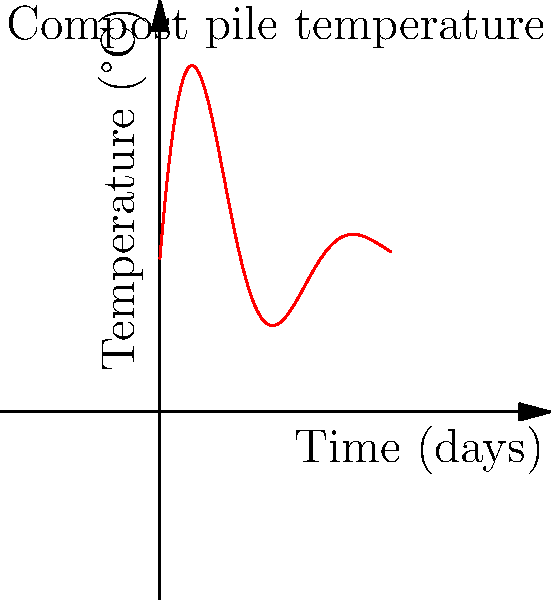At the Indian Land Fall Festival's sustainability booth, you're explaining the physics of composting. The graph shows the temperature variation in a compost pile over time. What physical process is primarily responsible for the initial temperature rise, and approximately how long does it take for the compost pile to reach its peak temperature? To answer this question, let's analyze the graph and the physics of composting:

1. Initial temperature rise:
   The graph shows a rapid increase in temperature at the beginning of the composting process. This is primarily due to the exothermic reactions of microorganisms breaking down organic matter.

2. Peak temperature:
   Looking at the graph, we can see that the temperature reaches its maximum at approximately 5 days.

3. Physical process explanation:
   a) As microorganisms decompose organic matter, they release heat as a byproduct of their metabolic activities.
   b) This process is exothermic, meaning it releases heat into the surrounding compost pile.
   c) The heat accumulates faster than it can dissipate, causing the temperature to rise.

4. Importance of temperature in composting:
   a) Higher temperatures (40-60°C) promote the growth of thermophilic bacteria, which are more efficient at breaking down organic matter.
   b) These temperatures also help kill pathogens and weed seeds in the compost.

5. Temperature decline:
   After the peak, the temperature gradually decreases as:
   a) The easily decomposable materials are consumed.
   b) The microbial activity slows down.
   c) Heat loss to the environment becomes more significant than heat generation.

The graph illustrates this entire process, showing the rapid initial rise, peak, and subsequent fluctuations as the compost matures.
Answer: Exothermic microbial activity; approximately 5 days 